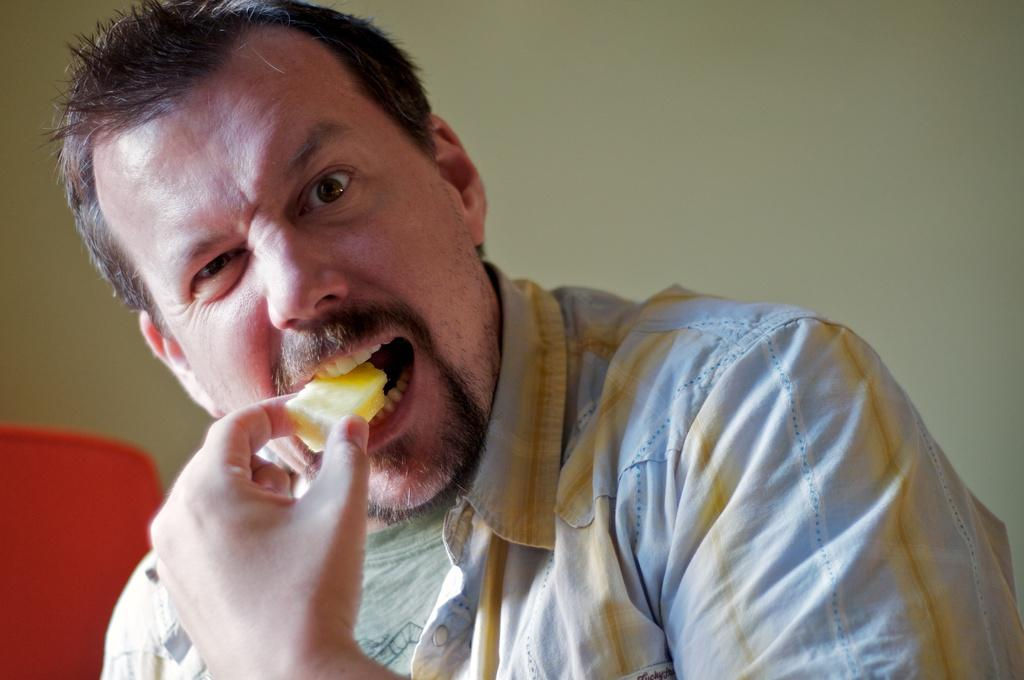What is happening in the image? There is a person in the image, and they are eating food. Can you describe the setting of the image? There is a wall in the background of the image. How many rings does the person have on their fingers in the image? There is no mention of rings in the image, so it is not possible to determine how many rings the person has on their fingers. 